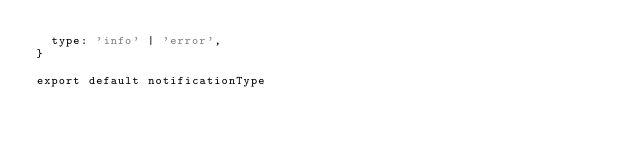<code> <loc_0><loc_0><loc_500><loc_500><_JavaScript_>  type: 'info' | 'error',
}

export default notificationType
</code> 